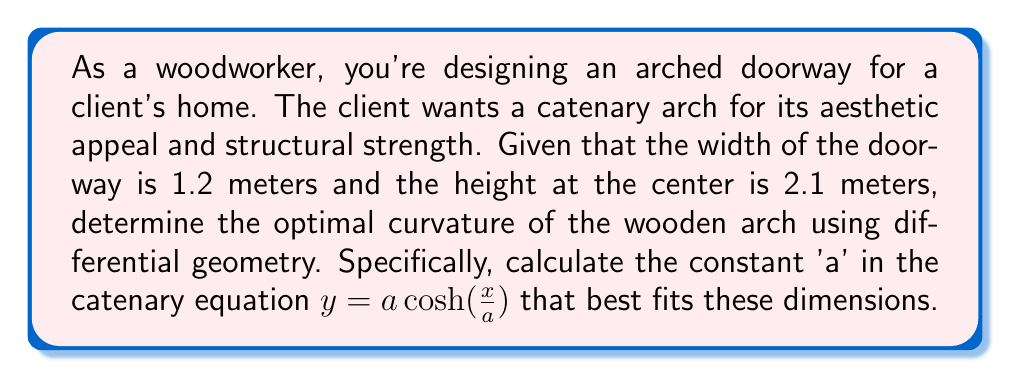Teach me how to tackle this problem. To solve this problem, we'll use the catenary equation and differential geometry concepts:

1) The catenary equation is given by $y = a \cosh(\frac{x}{a})$, where 'a' is the constant we need to determine.

2) Given the dimensions:
   Width = 1.2 meters, so x ranges from -0.6 to 0.6
   Height at center = 2.1 meters

3) At the center (x = 0), y = 2.1:
   $2.1 = a \cosh(0) = a$

4) At the edge (x = 0.6):
   $y = 2.1 \cosh(\frac{0.6}{2.1})$

5) The height at the edge should be 0:
   $0 = 2.1 \cosh(\frac{0.6}{2.1}) - y$

6) Solve this equation numerically (e.g., using Newton's method):
   Let $f(y) = 2.1 \cosh(\frac{0.6}{2.1}) - y$
   $f'(y) = -1$
   
   Starting with y₀ = 2.1:
   $y_{n+1} = y_n - \frac{f(y_n)}{f'(y_n)}$

   After a few iterations, we find y ≈ 1.9755

7) The curvature κ at any point is given by:
   $\kappa = \frac{1}{a} \operatorname{sech}^2(\frac{x}{a})$

8) At the vertex (x = 0), the curvature is:
   $\kappa_0 = \frac{1}{a} = \frac{1}{2.1} \approx 0.4762$

This curvature provides the optimal shape for the wooden arch, balancing aesthetic appeal and structural strength.
Answer: The optimal curvature for the wooden arch is achieved with $a = 2.1$ in the catenary equation $y = a \cosh(\frac{x}{a})$. The maximum curvature at the vertex is approximately 0.4762 m⁻¹. 